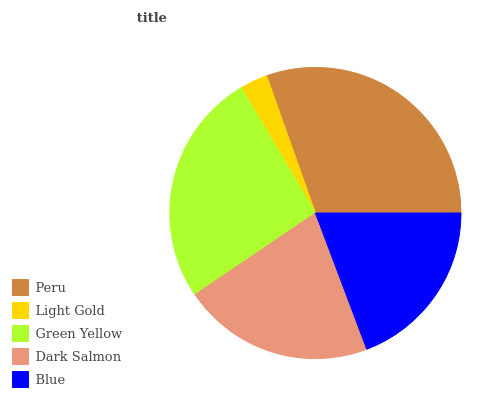Is Light Gold the minimum?
Answer yes or no. Yes. Is Peru the maximum?
Answer yes or no. Yes. Is Green Yellow the minimum?
Answer yes or no. No. Is Green Yellow the maximum?
Answer yes or no. No. Is Green Yellow greater than Light Gold?
Answer yes or no. Yes. Is Light Gold less than Green Yellow?
Answer yes or no. Yes. Is Light Gold greater than Green Yellow?
Answer yes or no. No. Is Green Yellow less than Light Gold?
Answer yes or no. No. Is Dark Salmon the high median?
Answer yes or no. Yes. Is Dark Salmon the low median?
Answer yes or no. Yes. Is Peru the high median?
Answer yes or no. No. Is Peru the low median?
Answer yes or no. No. 